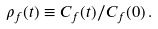Convert formula to latex. <formula><loc_0><loc_0><loc_500><loc_500>\rho _ { f } ( t ) \equiv C _ { f } ( t ) / C _ { f } ( 0 ) \, .</formula> 